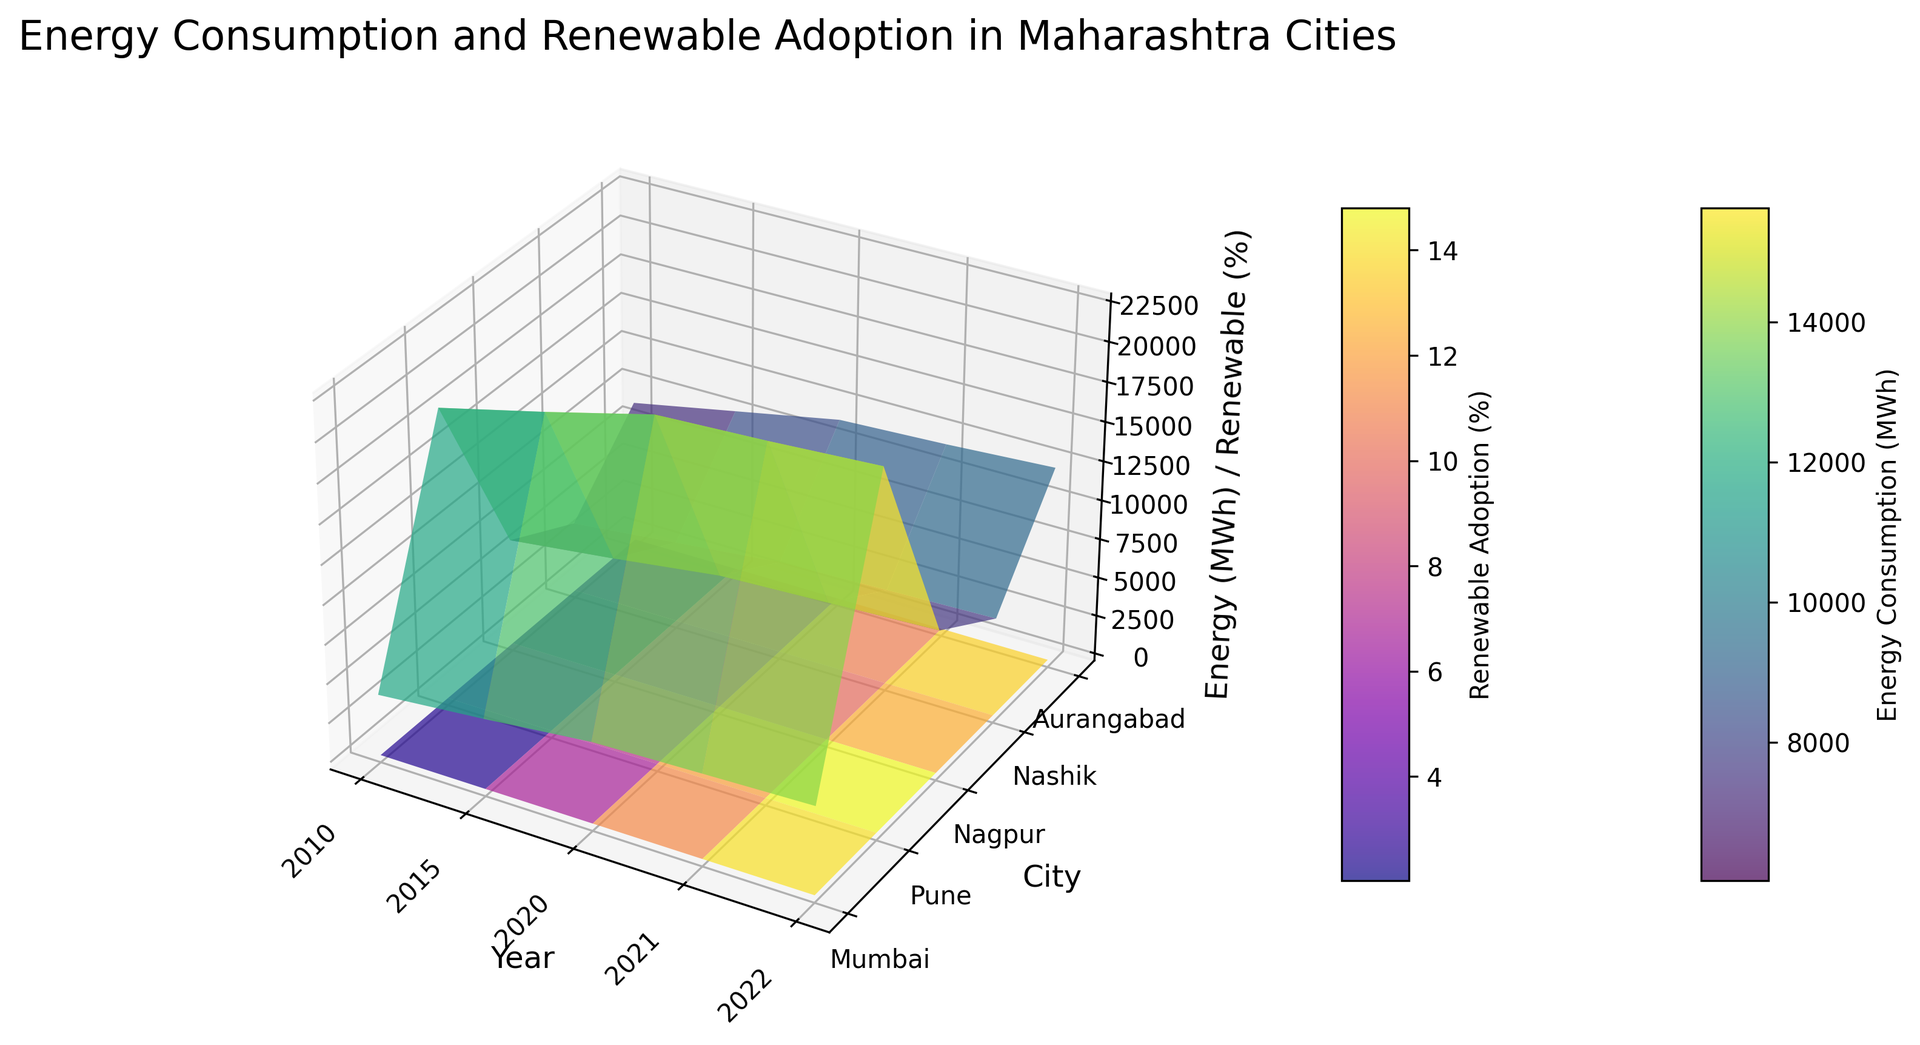What is the trend of energy consumption in Mumbai from 2010 to 2022? The surface plot will show the energy consumption values on the z-axis for Mumbai along the different year labels on the x-axis. Observe the trend of the height (z-values) for Mumbai's row. Notice that it starts at 18,500 MWh in 2010 and steadily increases to 22,500 MWh in 2022.
Answer: Increasing Compare the renewable energy adoption percentages in Pune and Nashik for the year 2022. Which city has adopted more renewable energy? Locate the z-values for Pune and Nashik in the column corresponding to the year 2022. Compare their heights. Pune has a z-value of 16.8%, whereas Nashik has a z-value of 13.5%. Hence, Pune has adopted more renewable energy.
Answer: Pune What is the difference in energy consumption between Nagpur and Aurangabad in the year 2021? Look at the heights corresponding to Nagpur and Aurangabad in the column for 2021. Nagpur's z-value is 8,800 MWh and Aurangabad's is 5,400 MWh. Subtract 5,400 from 8,800.
Answer: 3,400 MWh How has the renewable energy adoption changed in Nashik from 2010 to 2022? Observe the heights for Nashik along the renewable energy adoption surface from 2010 to 2022. It starts at 0.8% in 2010 and increases to 13.5% in 2022.
Answer: Increased In which year did Mumbai see the highest energy consumption? Look at the surface plot to find the peak height (z-value) in Mumbai's row. The highest point for Mumbai is in 2022 with an energy consumption of 22,500 MWh.
Answer: 2022 Compare the renewable energy adoption percentages of Nagpur and Pune in 2021. Which city shows a higher value? Check the z-values of Nagpur and Pune in the 2021 column on the renewable energy surface plot. Nagpur has a z-value of 11.5% and Pune has a z-value of 13.2%. Therefore, Pune has a higher value.
Answer: Pune Which city had the lowest energy consumption in 2010? Look at the heights (z-values) of the energy consumption surface for the year 2010. Aurangabad has the smallest height at 3,900 MWh.
Answer: Aurangabad How do the trends in renewable energy adoption compare between Mumbai and Aurangabad from 2015 to 2022? Follow the z-values for renewable energy adoption for Mumbai and Aurangabad from 2015 to 2022. Mumbai's values increase steadily from 5% to 18.5%, while Aurangabad's values increase from 2.2% to 12.8%. Both cities see an increase, but Mumbai's adoption is higher.
Answer: Both increase; Mumbai more What is the average renewable energy adoption percentage in Pune over the years shown? Sum the renewable adoption percentages for Pune across all years: 1.5 + 4.2 + 10.5 + 13.2 + 16.8. Divide by the number of years (5). Calculation: (1.5 + 4.2 + 10.5 + 13.2 + 16.8) / 5 = 46.2 / 5.
Answer: 9.24% In 2020, which city had the highest percentage of renewable energy adoption? Identify the tallest height (z-value) in the renewable energy surface plot for the year 2020. Pune has the highest z-value of 10.5%.
Answer: Pune 